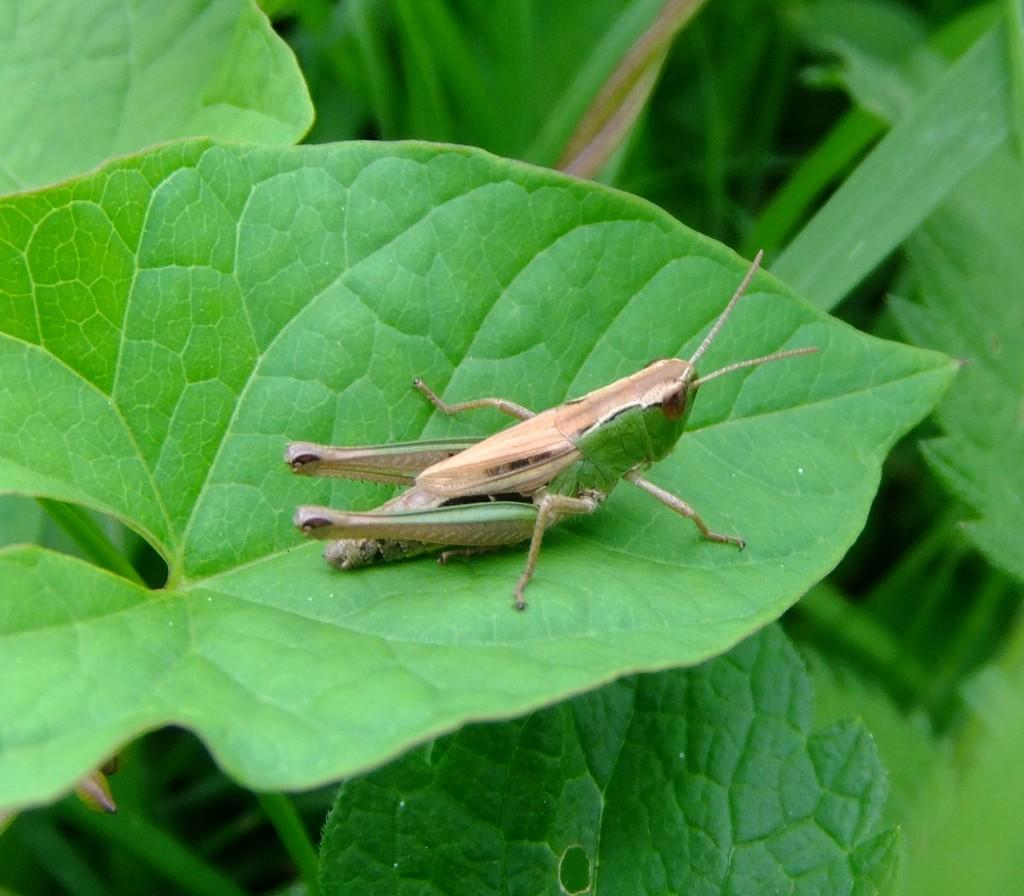What is on the leaf in the image? There is an insect on a leaf in the image. What can be seen in the background of the image? There are leaves visible in the background of the image. What type of destruction is the rabbit causing in the image? There is no rabbit present in the image, so it is not possible to determine if any destruction is occurring. 